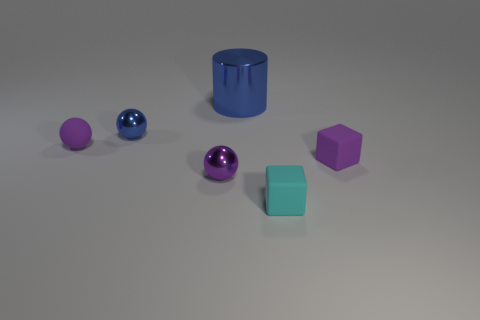There is a rubber block behind the cyan thing; is it the same color as the tiny rubber sphere?
Make the answer very short. Yes. What number of other shiny things have the same color as the large thing?
Your answer should be compact. 1. Is the number of small metallic spheres behind the cylinder the same as the number of small metal balls in front of the small blue sphere?
Make the answer very short. No. Are there any tiny blue metal spheres?
Offer a terse response. Yes. What is the size of the other metallic object that is the same shape as the small blue object?
Give a very brief answer. Small. How big is the sphere that is right of the tiny blue shiny object?
Provide a succinct answer. Small. Are there more small purple matte balls that are in front of the tiny blue metallic thing than big objects?
Offer a very short reply. No. The small cyan matte object is what shape?
Ensure brevity in your answer.  Cube. Is the color of the shiny ball that is behind the purple cube the same as the thing that is behind the small blue metallic ball?
Keep it short and to the point. Yes. Do the small purple shiny object and the tiny blue metallic object have the same shape?
Offer a very short reply. Yes. 